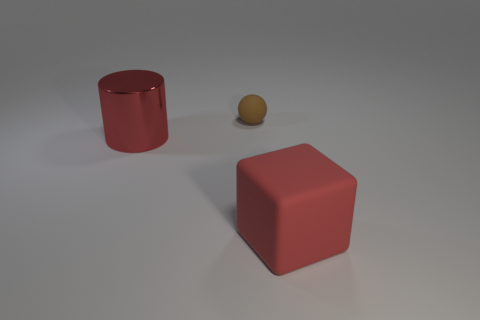Are there fewer shiny objects that are on the left side of the big red metal cylinder than green balls?
Provide a succinct answer. No. Is the material of the red cylinder the same as the large thing that is to the right of the shiny object?
Your answer should be very brief. No. What is the material of the red block?
Offer a very short reply. Rubber. What material is the tiny thing to the left of the matte thing that is to the right of the matte object that is behind the big cylinder?
Offer a terse response. Rubber. There is a large cylinder; does it have the same color as the large thing to the right of the large red shiny thing?
Offer a very short reply. Yes. Is there anything else that has the same shape as the large red rubber object?
Make the answer very short. No. What is the color of the rubber thing behind the large red thing to the right of the tiny sphere?
Your answer should be very brief. Brown. What number of tiny metallic objects are there?
Offer a very short reply. 0. How many matte things are either balls or red things?
Provide a succinct answer. 2. What number of cylinders are the same color as the cube?
Offer a terse response. 1. 